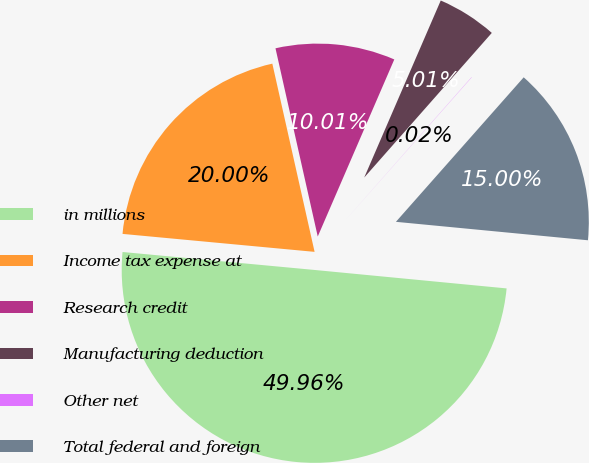Convert chart to OTSL. <chart><loc_0><loc_0><loc_500><loc_500><pie_chart><fcel>in millions<fcel>Income tax expense at<fcel>Research credit<fcel>Manufacturing deduction<fcel>Other net<fcel>Total federal and foreign<nl><fcel>49.96%<fcel>20.0%<fcel>10.01%<fcel>5.01%<fcel>0.02%<fcel>15.0%<nl></chart> 